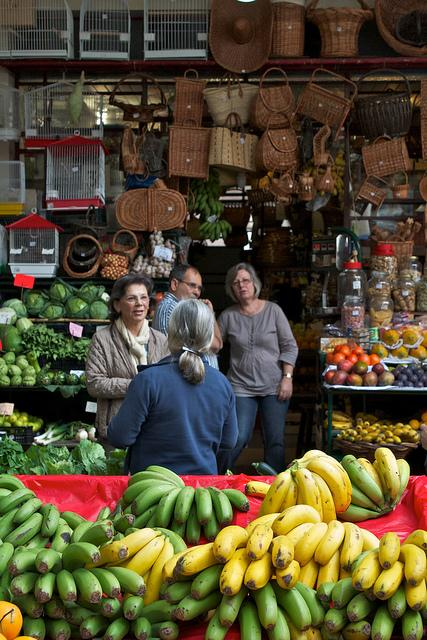What is meant to be kept in those cages? birds 